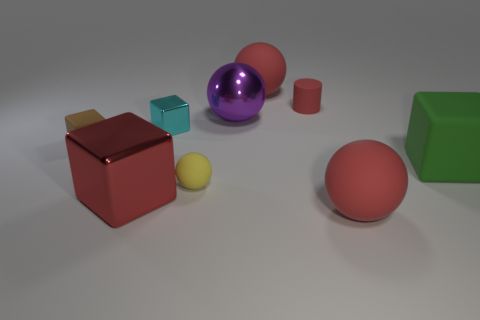Do the small rubber cylinder and the large metallic cube have the same color?
Ensure brevity in your answer.  Yes. There is a red shiny cube; does it have the same size as the ball on the left side of the big purple sphere?
Keep it short and to the point. No. What number of matte spheres are the same color as the tiny cylinder?
Keep it short and to the point. 2. What number of objects are either small blue metallic blocks or large metallic objects behind the cyan metallic thing?
Offer a very short reply. 1. Do the red matte ball that is in front of the purple metal sphere and the matte block that is to the left of the small matte cylinder have the same size?
Offer a terse response. No. Is there a cylinder made of the same material as the red cube?
Provide a short and direct response. No. What is the shape of the small cyan shiny object?
Provide a short and direct response. Cube. There is a big thing that is on the right side of the red ball in front of the brown block; what shape is it?
Offer a very short reply. Cube. How many other things are there of the same shape as the tiny brown thing?
Make the answer very short. 3. There is a red ball right of the small red cylinder behind the small metallic thing; how big is it?
Make the answer very short. Large. 